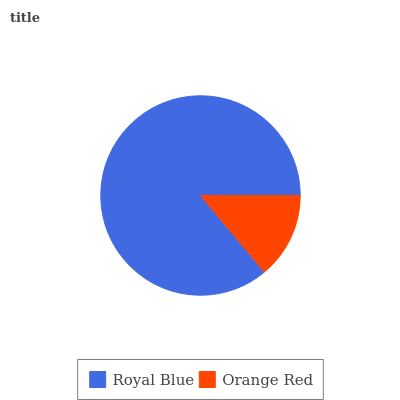Is Orange Red the minimum?
Answer yes or no. Yes. Is Royal Blue the maximum?
Answer yes or no. Yes. Is Orange Red the maximum?
Answer yes or no. No. Is Royal Blue greater than Orange Red?
Answer yes or no. Yes. Is Orange Red less than Royal Blue?
Answer yes or no. Yes. Is Orange Red greater than Royal Blue?
Answer yes or no. No. Is Royal Blue less than Orange Red?
Answer yes or no. No. Is Royal Blue the high median?
Answer yes or no. Yes. Is Orange Red the low median?
Answer yes or no. Yes. Is Orange Red the high median?
Answer yes or no. No. Is Royal Blue the low median?
Answer yes or no. No. 